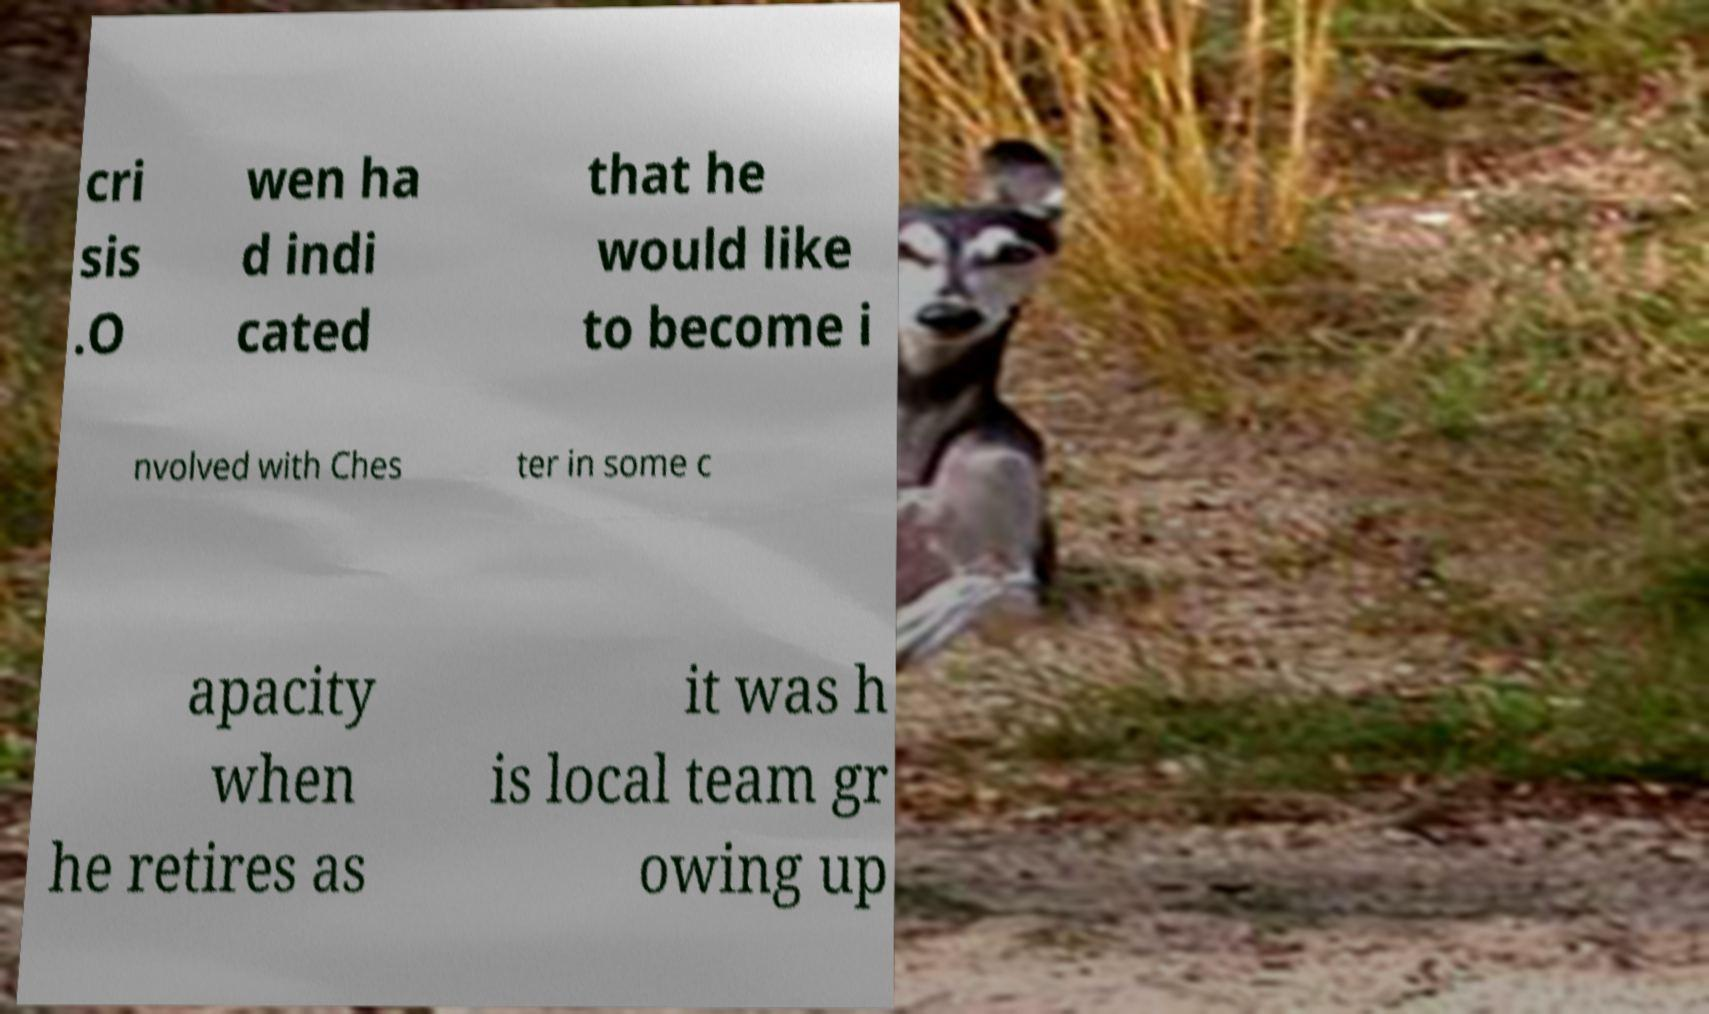There's text embedded in this image that I need extracted. Can you transcribe it verbatim? cri sis .O wen ha d indi cated that he would like to become i nvolved with Ches ter in some c apacity when he retires as it was h is local team gr owing up 